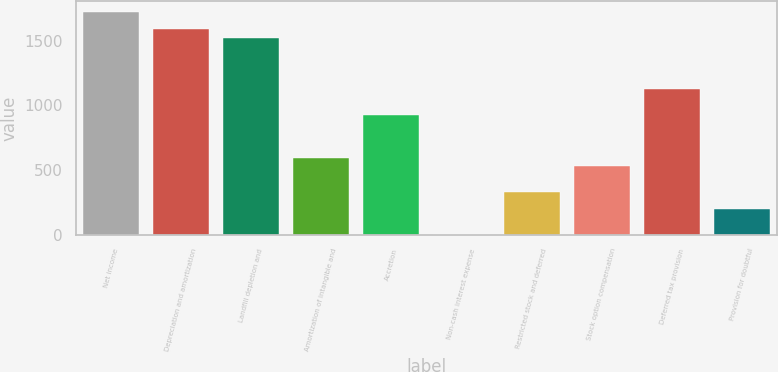Convert chart. <chart><loc_0><loc_0><loc_500><loc_500><bar_chart><fcel>Net income<fcel>Depreciation and amortization<fcel>Landfill depletion and<fcel>Amortization of intangible and<fcel>Accretion<fcel>Non-cash interest expense<fcel>Restricted stock and deferred<fcel>Stock option compensation<fcel>Deferred tax provision<fcel>Provision for doubtful<nl><fcel>1718.58<fcel>1586.42<fcel>1520.34<fcel>595.22<fcel>925.62<fcel>0.5<fcel>330.9<fcel>529.14<fcel>1123.86<fcel>198.74<nl></chart> 